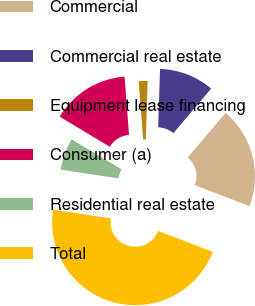Convert chart to OTSL. <chart><loc_0><loc_0><loc_500><loc_500><pie_chart><fcel>Commercial<fcel>Commercial real estate<fcel>Equipment lease financing<fcel>Consumer (a)<fcel>Residential real estate<fcel>Total<nl><fcel>19.66%<fcel>10.69%<fcel>1.72%<fcel>15.17%<fcel>6.21%<fcel>46.55%<nl></chart> 